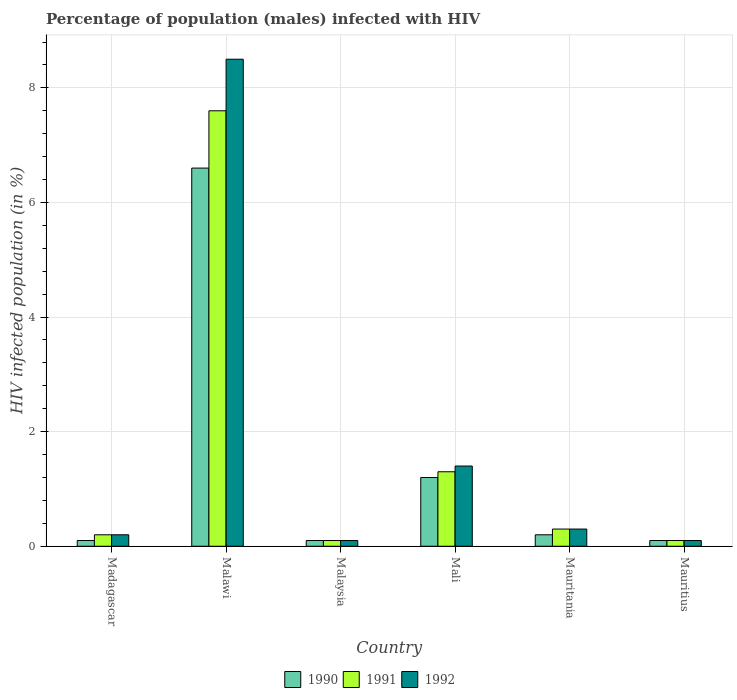How many groups of bars are there?
Provide a short and direct response. 6. Are the number of bars on each tick of the X-axis equal?
Offer a very short reply. Yes. What is the label of the 4th group of bars from the left?
Make the answer very short. Mali. In how many cases, is the number of bars for a given country not equal to the number of legend labels?
Keep it short and to the point. 0. Across all countries, what is the maximum percentage of HIV infected male population in 1992?
Keep it short and to the point. 8.5. In which country was the percentage of HIV infected male population in 1992 maximum?
Your response must be concise. Malawi. In which country was the percentage of HIV infected male population in 1990 minimum?
Give a very brief answer. Madagascar. What is the total percentage of HIV infected male population in 1990 in the graph?
Offer a very short reply. 8.3. What is the difference between the percentage of HIV infected male population in 1990 in Malawi and that in Mali?
Your answer should be very brief. 5.4. What is the difference between the percentage of HIV infected male population in 1991 in Malawi and the percentage of HIV infected male population in 1992 in Mauritania?
Your response must be concise. 7.3. What is the average percentage of HIV infected male population in 1991 per country?
Your response must be concise. 1.6. In how many countries, is the percentage of HIV infected male population in 1992 greater than 0.8 %?
Keep it short and to the point. 2. What is the ratio of the percentage of HIV infected male population in 1991 in Madagascar to that in Malawi?
Keep it short and to the point. 0.03. What is the difference between the highest and the second highest percentage of HIV infected male population in 1991?
Your answer should be compact. -1. Is the sum of the percentage of HIV infected male population in 1991 in Malawi and Malaysia greater than the maximum percentage of HIV infected male population in 1990 across all countries?
Keep it short and to the point. Yes. What does the 1st bar from the right in Malaysia represents?
Offer a very short reply. 1992. How many countries are there in the graph?
Offer a terse response. 6. Are the values on the major ticks of Y-axis written in scientific E-notation?
Give a very brief answer. No. Does the graph contain any zero values?
Your answer should be very brief. No. Does the graph contain grids?
Offer a very short reply. Yes. How many legend labels are there?
Provide a short and direct response. 3. How are the legend labels stacked?
Provide a short and direct response. Horizontal. What is the title of the graph?
Your response must be concise. Percentage of population (males) infected with HIV. What is the label or title of the X-axis?
Your response must be concise. Country. What is the label or title of the Y-axis?
Your answer should be compact. HIV infected population (in %). What is the HIV infected population (in %) of 1990 in Madagascar?
Your answer should be compact. 0.1. What is the HIV infected population (in %) of 1991 in Madagascar?
Provide a succinct answer. 0.2. What is the HIV infected population (in %) of 1992 in Madagascar?
Offer a terse response. 0.2. What is the HIV infected population (in %) of 1992 in Malawi?
Give a very brief answer. 8.5. What is the HIV infected population (in %) of 1991 in Malaysia?
Provide a succinct answer. 0.1. What is the HIV infected population (in %) of 1991 in Mali?
Your answer should be compact. 1.3. What is the HIV infected population (in %) in 1992 in Mali?
Offer a terse response. 1.4. What is the HIV infected population (in %) in 1990 in Mauritius?
Give a very brief answer. 0.1. What is the HIV infected population (in %) in 1992 in Mauritius?
Give a very brief answer. 0.1. Across all countries, what is the maximum HIV infected population (in %) in 1990?
Your response must be concise. 6.6. Across all countries, what is the maximum HIV infected population (in %) in 1991?
Provide a succinct answer. 7.6. Across all countries, what is the maximum HIV infected population (in %) of 1992?
Provide a succinct answer. 8.5. Across all countries, what is the minimum HIV infected population (in %) in 1990?
Offer a terse response. 0.1. Across all countries, what is the minimum HIV infected population (in %) in 1991?
Offer a very short reply. 0.1. Across all countries, what is the minimum HIV infected population (in %) in 1992?
Ensure brevity in your answer.  0.1. What is the total HIV infected population (in %) of 1990 in the graph?
Your answer should be compact. 8.3. What is the total HIV infected population (in %) of 1992 in the graph?
Offer a very short reply. 10.6. What is the difference between the HIV infected population (in %) in 1990 in Madagascar and that in Malaysia?
Keep it short and to the point. 0. What is the difference between the HIV infected population (in %) of 1991 in Madagascar and that in Malaysia?
Offer a very short reply. 0.1. What is the difference between the HIV infected population (in %) of 1992 in Madagascar and that in Malaysia?
Give a very brief answer. 0.1. What is the difference between the HIV infected population (in %) of 1990 in Madagascar and that in Mali?
Give a very brief answer. -1.1. What is the difference between the HIV infected population (in %) of 1991 in Madagascar and that in Mali?
Offer a very short reply. -1.1. What is the difference between the HIV infected population (in %) in 1992 in Madagascar and that in Mali?
Ensure brevity in your answer.  -1.2. What is the difference between the HIV infected population (in %) in 1991 in Madagascar and that in Mauritania?
Keep it short and to the point. -0.1. What is the difference between the HIV infected population (in %) of 1992 in Madagascar and that in Mauritania?
Your response must be concise. -0.1. What is the difference between the HIV infected population (in %) in 1990 in Madagascar and that in Mauritius?
Provide a succinct answer. 0. What is the difference between the HIV infected population (in %) of 1991 in Madagascar and that in Mauritius?
Provide a succinct answer. 0.1. What is the difference between the HIV infected population (in %) of 1992 in Madagascar and that in Mauritius?
Keep it short and to the point. 0.1. What is the difference between the HIV infected population (in %) of 1990 in Malawi and that in Malaysia?
Offer a very short reply. 6.5. What is the difference between the HIV infected population (in %) of 1990 in Malawi and that in Mali?
Provide a succinct answer. 5.4. What is the difference between the HIV infected population (in %) in 1992 in Malawi and that in Mali?
Your response must be concise. 7.1. What is the difference between the HIV infected population (in %) in 1990 in Malawi and that in Mauritania?
Your response must be concise. 6.4. What is the difference between the HIV infected population (in %) of 1991 in Malawi and that in Mauritius?
Offer a terse response. 7.5. What is the difference between the HIV infected population (in %) in 1992 in Malaysia and that in Mali?
Provide a short and direct response. -1.3. What is the difference between the HIV infected population (in %) of 1990 in Malaysia and that in Mauritius?
Offer a very short reply. 0. What is the difference between the HIV infected population (in %) in 1991 in Malaysia and that in Mauritius?
Your answer should be compact. 0. What is the difference between the HIV infected population (in %) of 1990 in Mali and that in Mauritania?
Ensure brevity in your answer.  1. What is the difference between the HIV infected population (in %) of 1991 in Mali and that in Mauritius?
Offer a very short reply. 1.2. What is the difference between the HIV infected population (in %) of 1992 in Mali and that in Mauritius?
Your answer should be very brief. 1.3. What is the difference between the HIV infected population (in %) in 1990 in Mauritania and that in Mauritius?
Keep it short and to the point. 0.1. What is the difference between the HIV infected population (in %) in 1991 in Mauritania and that in Mauritius?
Offer a terse response. 0.2. What is the difference between the HIV infected population (in %) in 1992 in Mauritania and that in Mauritius?
Offer a very short reply. 0.2. What is the difference between the HIV infected population (in %) of 1990 in Madagascar and the HIV infected population (in %) of 1991 in Malawi?
Your answer should be compact. -7.5. What is the difference between the HIV infected population (in %) of 1991 in Madagascar and the HIV infected population (in %) of 1992 in Malawi?
Offer a very short reply. -8.3. What is the difference between the HIV infected population (in %) of 1990 in Madagascar and the HIV infected population (in %) of 1991 in Malaysia?
Make the answer very short. 0. What is the difference between the HIV infected population (in %) of 1990 in Madagascar and the HIV infected population (in %) of 1992 in Malaysia?
Offer a very short reply. 0. What is the difference between the HIV infected population (in %) in 1991 in Madagascar and the HIV infected population (in %) in 1992 in Malaysia?
Give a very brief answer. 0.1. What is the difference between the HIV infected population (in %) in 1990 in Madagascar and the HIV infected population (in %) in 1991 in Mali?
Your answer should be very brief. -1.2. What is the difference between the HIV infected population (in %) of 1990 in Madagascar and the HIV infected population (in %) of 1992 in Mali?
Give a very brief answer. -1.3. What is the difference between the HIV infected population (in %) in 1991 in Madagascar and the HIV infected population (in %) in 1992 in Mali?
Keep it short and to the point. -1.2. What is the difference between the HIV infected population (in %) of 1990 in Madagascar and the HIV infected population (in %) of 1992 in Mauritius?
Your response must be concise. 0. What is the difference between the HIV infected population (in %) in 1990 in Malawi and the HIV infected population (in %) in 1991 in Malaysia?
Ensure brevity in your answer.  6.5. What is the difference between the HIV infected population (in %) of 1991 in Malawi and the HIV infected population (in %) of 1992 in Malaysia?
Your response must be concise. 7.5. What is the difference between the HIV infected population (in %) in 1990 in Malawi and the HIV infected population (in %) in 1991 in Mali?
Offer a very short reply. 5.3. What is the difference between the HIV infected population (in %) in 1990 in Malawi and the HIV infected population (in %) in 1992 in Mali?
Provide a short and direct response. 5.2. What is the difference between the HIV infected population (in %) of 1990 in Malawi and the HIV infected population (in %) of 1991 in Mauritania?
Provide a short and direct response. 6.3. What is the difference between the HIV infected population (in %) of 1990 in Malawi and the HIV infected population (in %) of 1992 in Mauritius?
Ensure brevity in your answer.  6.5. What is the difference between the HIV infected population (in %) in 1991 in Malawi and the HIV infected population (in %) in 1992 in Mauritius?
Ensure brevity in your answer.  7.5. What is the difference between the HIV infected population (in %) of 1991 in Malaysia and the HIV infected population (in %) of 1992 in Mali?
Your answer should be very brief. -1.3. What is the difference between the HIV infected population (in %) in 1990 in Malaysia and the HIV infected population (in %) in 1992 in Mauritius?
Keep it short and to the point. 0. What is the difference between the HIV infected population (in %) of 1991 in Mali and the HIV infected population (in %) of 1992 in Mauritania?
Provide a succinct answer. 1. What is the difference between the HIV infected population (in %) in 1990 in Mauritania and the HIV infected population (in %) in 1992 in Mauritius?
Ensure brevity in your answer.  0.1. What is the average HIV infected population (in %) in 1990 per country?
Ensure brevity in your answer.  1.38. What is the average HIV infected population (in %) of 1991 per country?
Your answer should be very brief. 1.6. What is the average HIV infected population (in %) of 1992 per country?
Offer a very short reply. 1.77. What is the difference between the HIV infected population (in %) in 1991 and HIV infected population (in %) in 1992 in Madagascar?
Give a very brief answer. 0. What is the difference between the HIV infected population (in %) in 1990 and HIV infected population (in %) in 1991 in Malawi?
Ensure brevity in your answer.  -1. What is the difference between the HIV infected population (in %) in 1991 and HIV infected population (in %) in 1992 in Malawi?
Provide a short and direct response. -0.9. What is the difference between the HIV infected population (in %) in 1990 and HIV infected population (in %) in 1992 in Mauritania?
Ensure brevity in your answer.  -0.1. What is the difference between the HIV infected population (in %) of 1991 and HIV infected population (in %) of 1992 in Mauritania?
Provide a succinct answer. 0. What is the difference between the HIV infected population (in %) in 1990 and HIV infected population (in %) in 1991 in Mauritius?
Ensure brevity in your answer.  0. What is the ratio of the HIV infected population (in %) of 1990 in Madagascar to that in Malawi?
Make the answer very short. 0.02. What is the ratio of the HIV infected population (in %) of 1991 in Madagascar to that in Malawi?
Your response must be concise. 0.03. What is the ratio of the HIV infected population (in %) in 1992 in Madagascar to that in Malawi?
Offer a terse response. 0.02. What is the ratio of the HIV infected population (in %) in 1990 in Madagascar to that in Malaysia?
Provide a short and direct response. 1. What is the ratio of the HIV infected population (in %) of 1991 in Madagascar to that in Malaysia?
Give a very brief answer. 2. What is the ratio of the HIV infected population (in %) of 1992 in Madagascar to that in Malaysia?
Ensure brevity in your answer.  2. What is the ratio of the HIV infected population (in %) of 1990 in Madagascar to that in Mali?
Offer a very short reply. 0.08. What is the ratio of the HIV infected population (in %) in 1991 in Madagascar to that in Mali?
Make the answer very short. 0.15. What is the ratio of the HIV infected population (in %) in 1992 in Madagascar to that in Mali?
Offer a very short reply. 0.14. What is the ratio of the HIV infected population (in %) of 1990 in Madagascar to that in Mauritania?
Your response must be concise. 0.5. What is the ratio of the HIV infected population (in %) of 1991 in Madagascar to that in Mauritania?
Keep it short and to the point. 0.67. What is the ratio of the HIV infected population (in %) in 1992 in Madagascar to that in Mauritania?
Keep it short and to the point. 0.67. What is the ratio of the HIV infected population (in %) of 1990 in Madagascar to that in Mauritius?
Give a very brief answer. 1. What is the ratio of the HIV infected population (in %) of 1990 in Malawi to that in Malaysia?
Your response must be concise. 66. What is the ratio of the HIV infected population (in %) in 1992 in Malawi to that in Malaysia?
Your answer should be very brief. 85. What is the ratio of the HIV infected population (in %) of 1991 in Malawi to that in Mali?
Provide a succinct answer. 5.85. What is the ratio of the HIV infected population (in %) in 1992 in Malawi to that in Mali?
Offer a very short reply. 6.07. What is the ratio of the HIV infected population (in %) in 1990 in Malawi to that in Mauritania?
Make the answer very short. 33. What is the ratio of the HIV infected population (in %) in 1991 in Malawi to that in Mauritania?
Your answer should be very brief. 25.33. What is the ratio of the HIV infected population (in %) in 1992 in Malawi to that in Mauritania?
Make the answer very short. 28.33. What is the ratio of the HIV infected population (in %) in 1990 in Malawi to that in Mauritius?
Give a very brief answer. 66. What is the ratio of the HIV infected population (in %) in 1991 in Malawi to that in Mauritius?
Make the answer very short. 76. What is the ratio of the HIV infected population (in %) of 1992 in Malawi to that in Mauritius?
Give a very brief answer. 85. What is the ratio of the HIV infected population (in %) of 1990 in Malaysia to that in Mali?
Give a very brief answer. 0.08. What is the ratio of the HIV infected population (in %) of 1991 in Malaysia to that in Mali?
Offer a terse response. 0.08. What is the ratio of the HIV infected population (in %) in 1992 in Malaysia to that in Mali?
Give a very brief answer. 0.07. What is the ratio of the HIV infected population (in %) in 1992 in Malaysia to that in Mauritania?
Make the answer very short. 0.33. What is the ratio of the HIV infected population (in %) of 1990 in Malaysia to that in Mauritius?
Keep it short and to the point. 1. What is the ratio of the HIV infected population (in %) of 1991 in Mali to that in Mauritania?
Keep it short and to the point. 4.33. What is the ratio of the HIV infected population (in %) in 1992 in Mali to that in Mauritania?
Keep it short and to the point. 4.67. What is the ratio of the HIV infected population (in %) in 1990 in Mauritania to that in Mauritius?
Offer a very short reply. 2. What is the difference between the highest and the second highest HIV infected population (in %) of 1991?
Your answer should be compact. 6.3. What is the difference between the highest and the second highest HIV infected population (in %) in 1992?
Provide a succinct answer. 7.1. What is the difference between the highest and the lowest HIV infected population (in %) in 1990?
Your answer should be compact. 6.5. What is the difference between the highest and the lowest HIV infected population (in %) in 1991?
Provide a short and direct response. 7.5. 